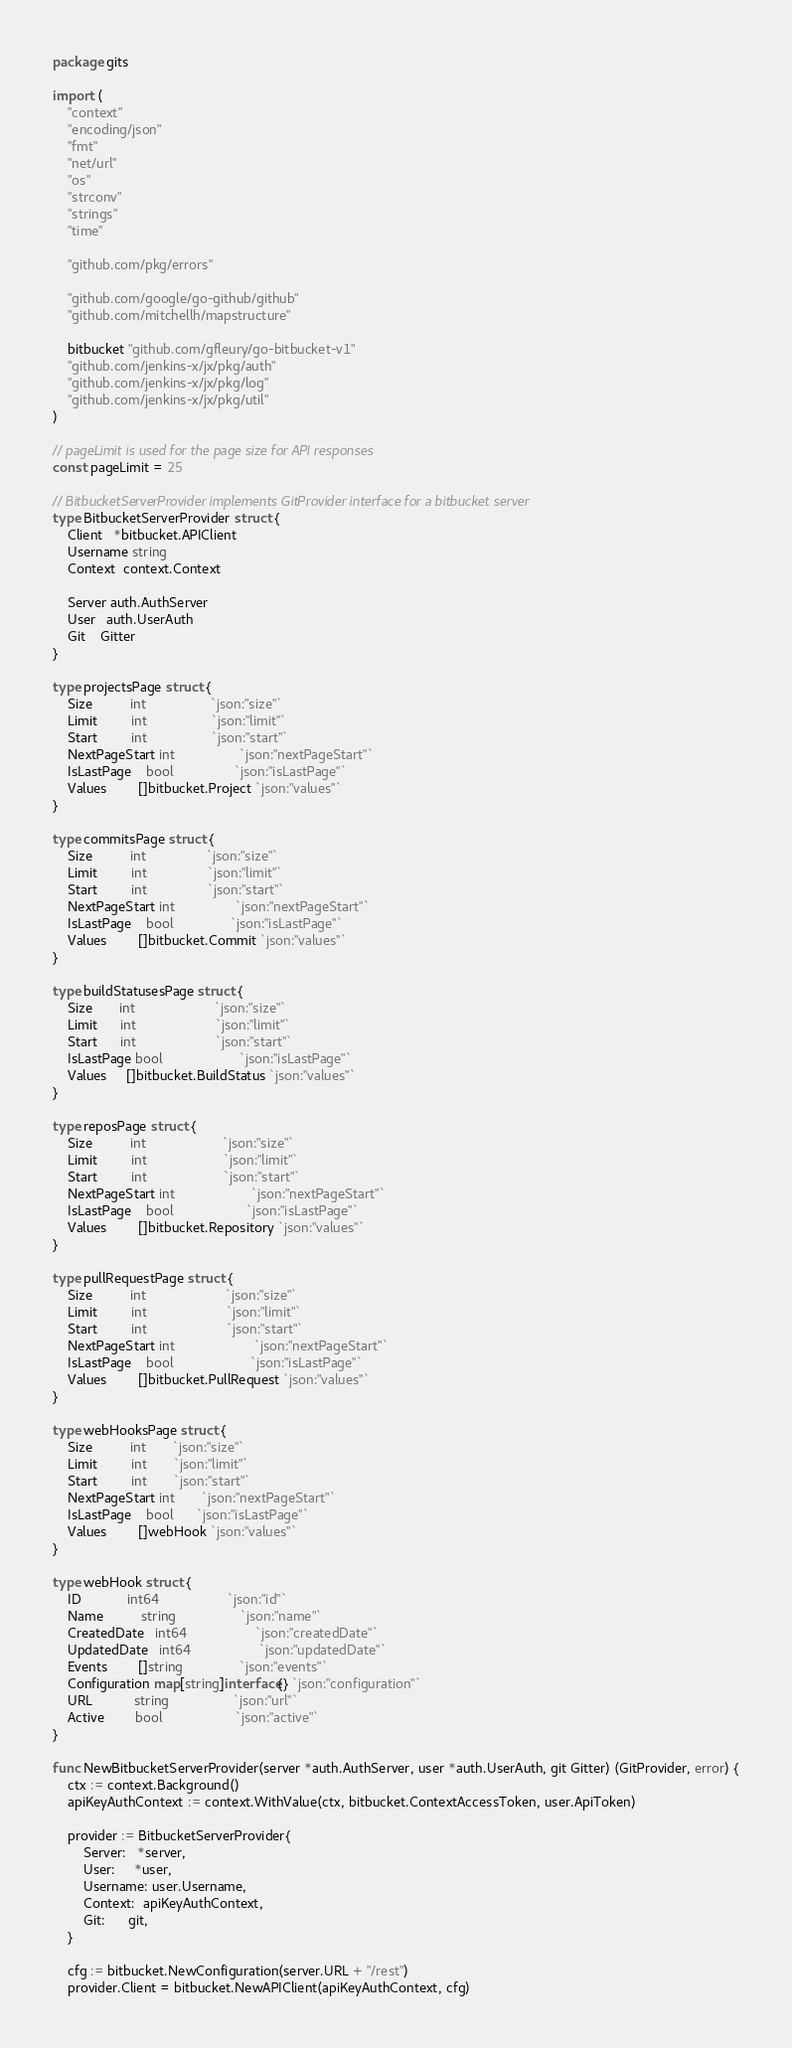<code> <loc_0><loc_0><loc_500><loc_500><_Go_>package gits

import (
	"context"
	"encoding/json"
	"fmt"
	"net/url"
	"os"
	"strconv"
	"strings"
	"time"

	"github.com/pkg/errors"

	"github.com/google/go-github/github"
	"github.com/mitchellh/mapstructure"

	bitbucket "github.com/gfleury/go-bitbucket-v1"
	"github.com/jenkins-x/jx/pkg/auth"
	"github.com/jenkins-x/jx/pkg/log"
	"github.com/jenkins-x/jx/pkg/util"
)

// pageLimit is used for the page size for API responses
const pageLimit = 25

// BitbucketServerProvider implements GitProvider interface for a bitbucket server
type BitbucketServerProvider struct {
	Client   *bitbucket.APIClient
	Username string
	Context  context.Context

	Server auth.AuthServer
	User   auth.UserAuth
	Git    Gitter
}

type projectsPage struct {
	Size          int                 `json:"size"`
	Limit         int                 `json:"limit"`
	Start         int                 `json:"start"`
	NextPageStart int                 `json:"nextPageStart"`
	IsLastPage    bool                `json:"isLastPage"`
	Values        []bitbucket.Project `json:"values"`
}

type commitsPage struct {
	Size          int                `json:"size"`
	Limit         int                `json:"limit"`
	Start         int                `json:"start"`
	NextPageStart int                `json:"nextPageStart"`
	IsLastPage    bool               `json:"isLastPage"`
	Values        []bitbucket.Commit `json:"values"`
}

type buildStatusesPage struct {
	Size       int                     `json:"size"`
	Limit      int                     `json:"limit"`
	Start      int                     `json:"start"`
	IsLastPage bool                    `json:"isLastPage"`
	Values     []bitbucket.BuildStatus `json:"values"`
}

type reposPage struct {
	Size          int                    `json:"size"`
	Limit         int                    `json:"limit"`
	Start         int                    `json:"start"`
	NextPageStart int                    `json:"nextPageStart"`
	IsLastPage    bool                   `json:"isLastPage"`
	Values        []bitbucket.Repository `json:"values"`
}

type pullRequestPage struct {
	Size          int                     `json:"size"`
	Limit         int                     `json:"limit"`
	Start         int                     `json:"start"`
	NextPageStart int                     `json:"nextPageStart"`
	IsLastPage    bool                    `json:"isLastPage"`
	Values        []bitbucket.PullRequest `json:"values"`
}

type webHooksPage struct {
	Size          int       `json:"size"`
	Limit         int       `json:"limit"`
	Start         int       `json:"start"`
	NextPageStart int       `json:"nextPageStart"`
	IsLastPage    bool      `json:"isLastPage"`
	Values        []webHook `json:"values"`
}

type webHook struct {
	ID            int64                  `json:"id"`
	Name          string                 `json:"name"`
	CreatedDate   int64                  `json:"createdDate"`
	UpdatedDate   int64                  `json:"updatedDate"`
	Events        []string               `json:"events"`
	Configuration map[string]interface{} `json:"configuration"`
	URL           string                 `json:"url"`
	Active        bool                   `json:"active"`
}

func NewBitbucketServerProvider(server *auth.AuthServer, user *auth.UserAuth, git Gitter) (GitProvider, error) {
	ctx := context.Background()
	apiKeyAuthContext := context.WithValue(ctx, bitbucket.ContextAccessToken, user.ApiToken)

	provider := BitbucketServerProvider{
		Server:   *server,
		User:     *user,
		Username: user.Username,
		Context:  apiKeyAuthContext,
		Git:      git,
	}

	cfg := bitbucket.NewConfiguration(server.URL + "/rest")
	provider.Client = bitbucket.NewAPIClient(apiKeyAuthContext, cfg)
</code> 